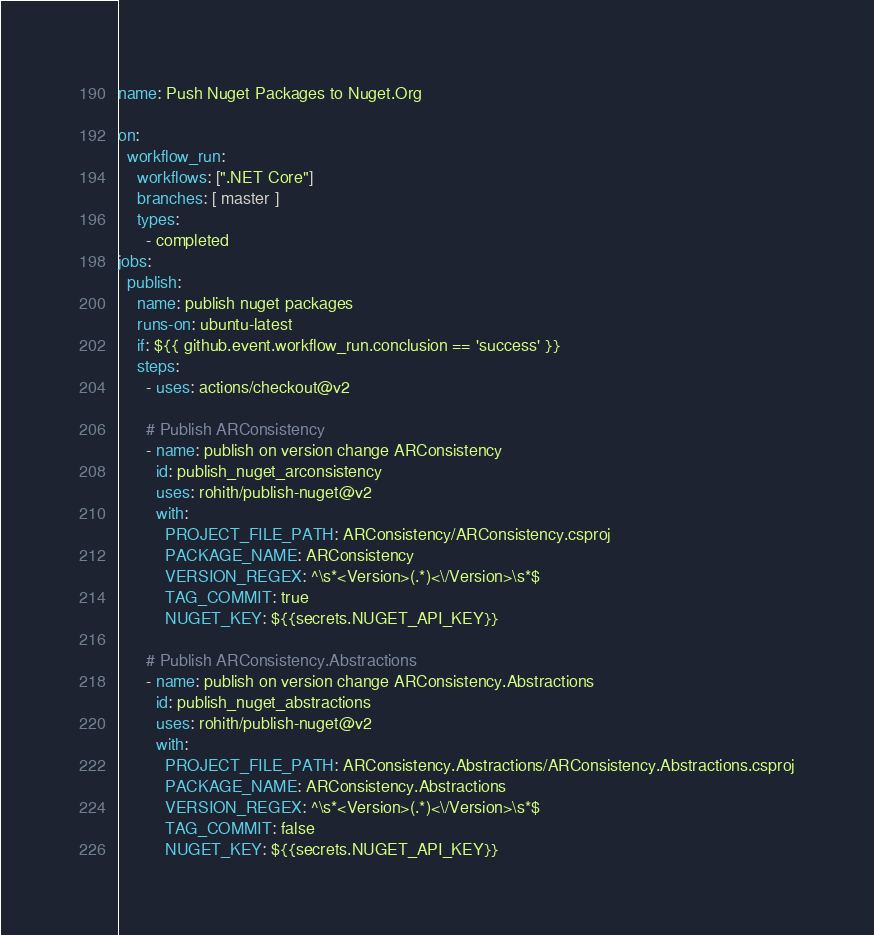Convert code to text. <code><loc_0><loc_0><loc_500><loc_500><_YAML_>name: Push Nuget Packages to Nuget.Org

on:
  workflow_run:
    workflows: [".NET Core"]
    branches: [ master ]
    types:
      - completed
jobs:
  publish:
    name: publish nuget packages
    runs-on: ubuntu-latest
    if: ${{ github.event.workflow_run.conclusion == 'success' }}
    steps:
      - uses: actions/checkout@v2
        
      # Publish ARConsistency
      - name: publish on version change ARConsistency
        id: publish_nuget_arconsistency
        uses: rohith/publish-nuget@v2
        with:
          PROJECT_FILE_PATH: ARConsistency/ARConsistency.csproj
          PACKAGE_NAME: ARConsistency
          VERSION_REGEX: ^\s*<Version>(.*)<\/Version>\s*$
          TAG_COMMIT: true
          NUGET_KEY: ${{secrets.NUGET_API_KEY}}
          
      # Publish ARConsistency.Abstractions
      - name: publish on version change ARConsistency.Abstractions
        id: publish_nuget_abstractions
        uses: rohith/publish-nuget@v2
        with:
          PROJECT_FILE_PATH: ARConsistency.Abstractions/ARConsistency.Abstractions.csproj
          PACKAGE_NAME: ARConsistency.Abstractions
          VERSION_REGEX: ^\s*<Version>(.*)<\/Version>\s*$
          TAG_COMMIT: false
          NUGET_KEY: ${{secrets.NUGET_API_KEY}}
</code> 